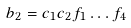<formula> <loc_0><loc_0><loc_500><loc_500>b _ { 2 } = c _ { 1 } c _ { 2 } f _ { 1 } \dots f _ { 4 }</formula> 